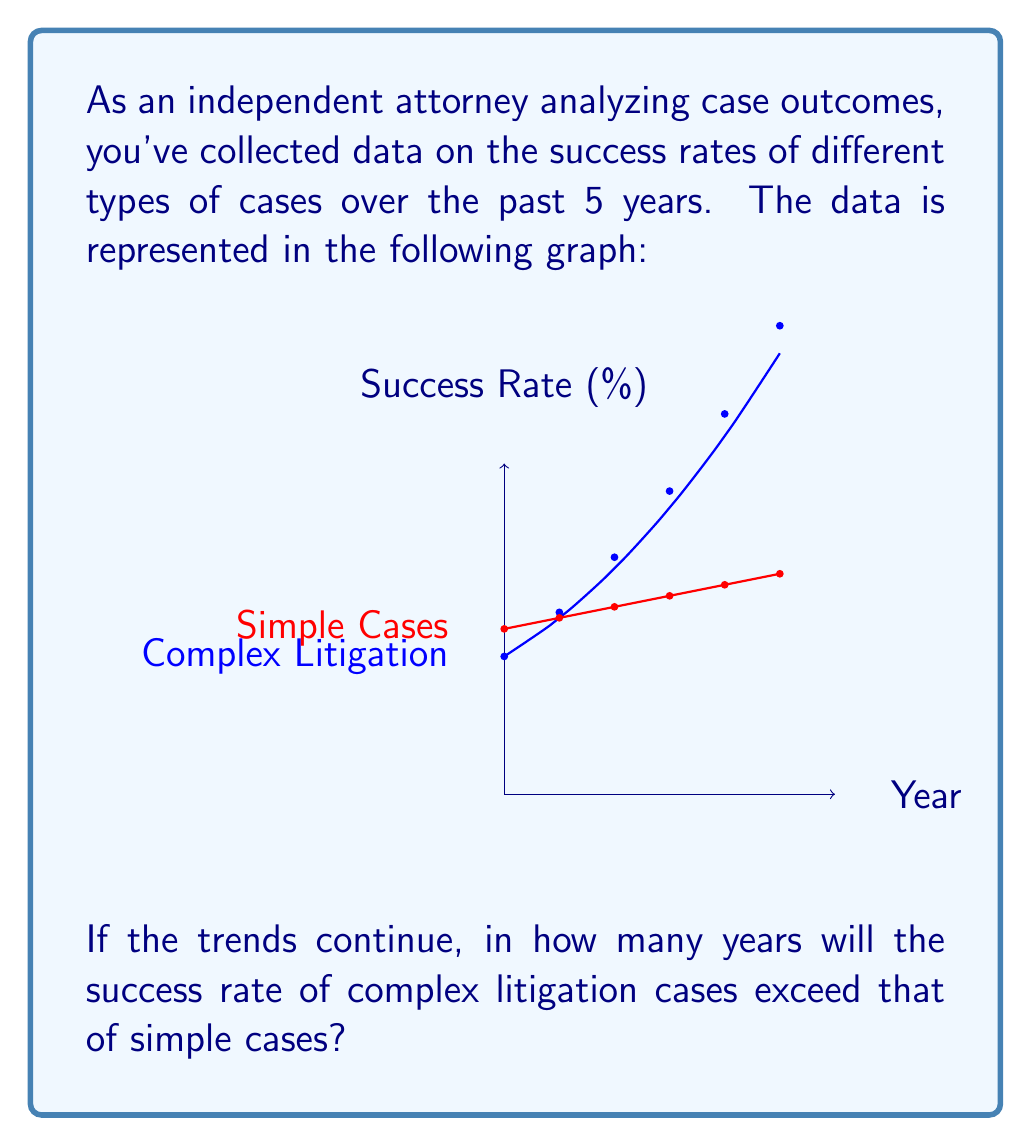Show me your answer to this math problem. To solve this problem, we need to:
1. Identify the equations for both trends
2. Set up an inequality to find when complex litigation success rate exceeds simple cases
3. Solve the inequality for the time variable

1. From the graph, we can deduce:
   Complex Litigation: $y = 50 + 5x + 0.5x^2$ (quadratic growth)
   Simple Cases: $y = 60 + 2x$ (linear growth)
   where $x$ is the number of years from the start of the data (so $x=5$ represents the current year)

2. We want to find when:
   $50 + 5x + 0.5x^2 > 60 + 2x$

3. Solving the inequality:
   $50 + 5x + 0.5x^2 > 60 + 2x$
   $0.5x^2 + 3x - 10 > 0$
   
   This is a quadratic inequality. We need to find its roots:
   $x = \frac{-3 \pm \sqrt{3^2 + 4(0.5)(10)}}{2(0.5)} = \frac{-3 \pm \sqrt{29}}{1} = -3 \pm \sqrt{29}$
   
   The positive root is $x = -3 + \sqrt{29} \approx 2.39$

   Since $x=5$ represents the current year, we need to add 5 to our result:
   $2.39 + 5 = 7.39$

   Rounding up to the nearest year, it will take 8 years from the start of the data, or 3 years from now.
Answer: 3 years 